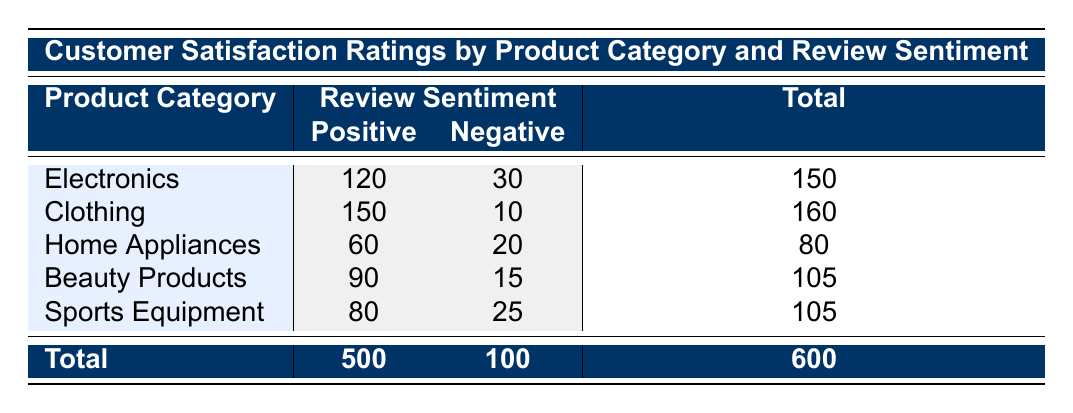What is the highest customer satisfaction rating in the Electronics category? In the Electronics category, there are two review sentiments: Positive with 120 ratings and Negative with 30 ratings. The highest rating between them is 120 for Positive reviews.
Answer: 120 How many total customer satisfaction ratings are there for Beauty Products? In the Beauty Products category, the Positive ratings are 90 and the Negative ratings are 15. Adding both gives 90 + 15 = 105 total ratings.
Answer: 105 Is the number of Positive ratings for Clothing greater than the number of Negative ratings for Home Appliances? The Clothing category has Positive ratings of 150, while Home Appliances has Negative ratings of 20. Since 150 is greater than 20, the statement is true.
Answer: Yes What is the total number of Negative customer satisfaction ratings across all product categories? To find the total number of Negative ratings, we sum the Negative ratings from each category: 30 (Electronics) + 10 (Clothing) + 20 (Home Appliances) + 15 (Beauty Products) + 25 (Sports Equipment) = 100.
Answer: 100 Which product category has the largest difference between Positive and Negative ratings? To find the largest difference, calculate the difference for each category: Electronics: 120 - 30 = 90, Clothing: 150 - 10 = 140, Home Appliances: 60 - 20 = 40, Beauty Products: 90 - 15 = 75, Sports Equipment: 80 - 25 = 55. The largest difference is 140 for Clothing.
Answer: Clothing What is the average customer satisfaction rating for all products based on Positive reviews only? The total Positive ratings from all categories are: 120 (Electronics) + 150 (Clothing) + 60 (Home Appliances) + 90 (Beauty Products) + 80 (Sports Equipment) = 500. There are 5 categories, so the average is 500 / 5 = 100.
Answer: 100 Does the total number of customer satisfaction ratings for Sports Equipment exceed that of Home Appliances? Sports Equipment total ratings are 80 (Positive) + 25 (Negative) = 105, while Home Appliances total ratings are 60 (Positive) + 20 (Negative) = 80. Since 105 is greater than 80, the answer is yes.
Answer: Yes What proportion of Positive ratings comes from the Clothing category? The total Positive ratings from all categories is 500. Clothing has 150 Positive ratings, so the proportion is 150 / 500 = 0.3 or 30%.
Answer: 30% 